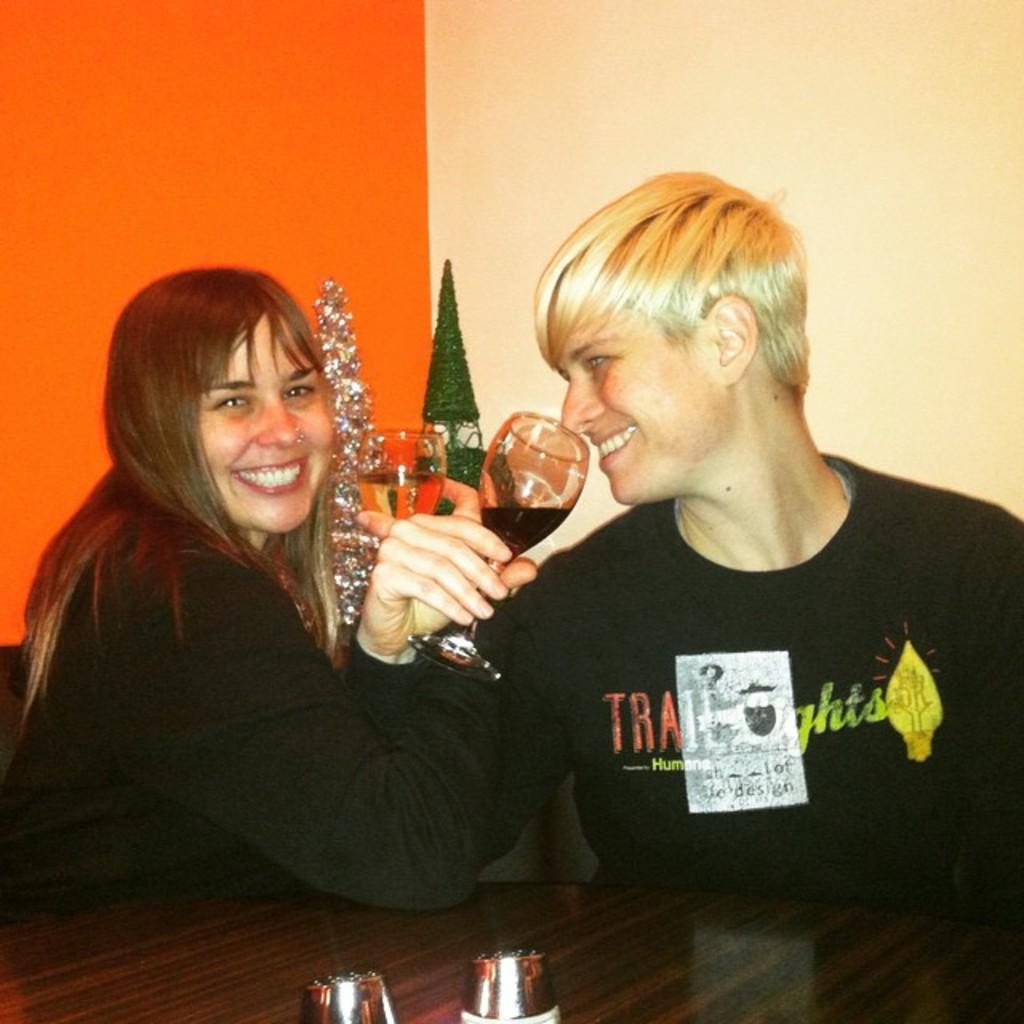Can you describe this image briefly? In this picture we can see a women and a man, they are smiling and they hold a glass with their hands. On the background there is a wall. And this is the table. 